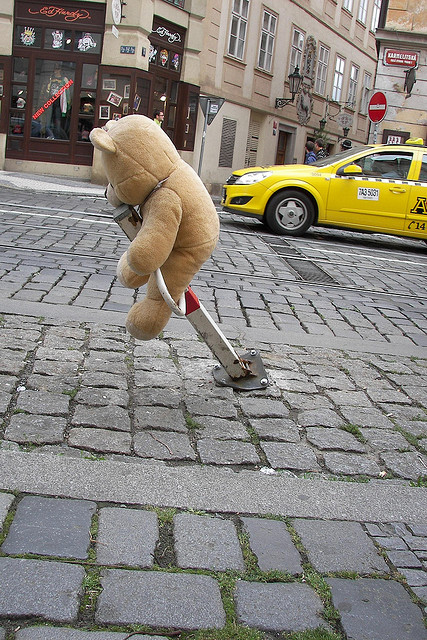Identify the text displayed in this image. A 14 